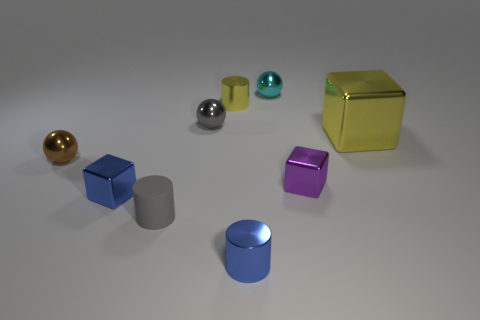How many other things are there of the same color as the matte cylinder?
Keep it short and to the point. 1. Is there anything else that is the same shape as the small purple metallic object?
Provide a succinct answer. Yes. Is the number of tiny rubber cylinders that are right of the tiny yellow cylinder the same as the number of small blue blocks?
Ensure brevity in your answer.  No. Does the big shiny thing have the same color as the shiny block left of the purple block?
Provide a short and direct response. No. The shiny thing that is in front of the large shiny cube and on the right side of the small cyan metallic thing is what color?
Offer a terse response. Purple. What number of metallic objects are on the right side of the gray thing that is in front of the large thing?
Make the answer very short. 6. Is there a tiny yellow metallic thing that has the same shape as the big thing?
Give a very brief answer. No. There is a tiny blue shiny thing right of the small gray rubber cylinder; is it the same shape as the yellow metal thing in front of the gray metal sphere?
Your answer should be very brief. No. How many things are metal spheres or tiny yellow shiny cylinders?
Your response must be concise. 4. What is the size of the yellow thing that is the same shape as the small purple metal object?
Your answer should be compact. Large. 